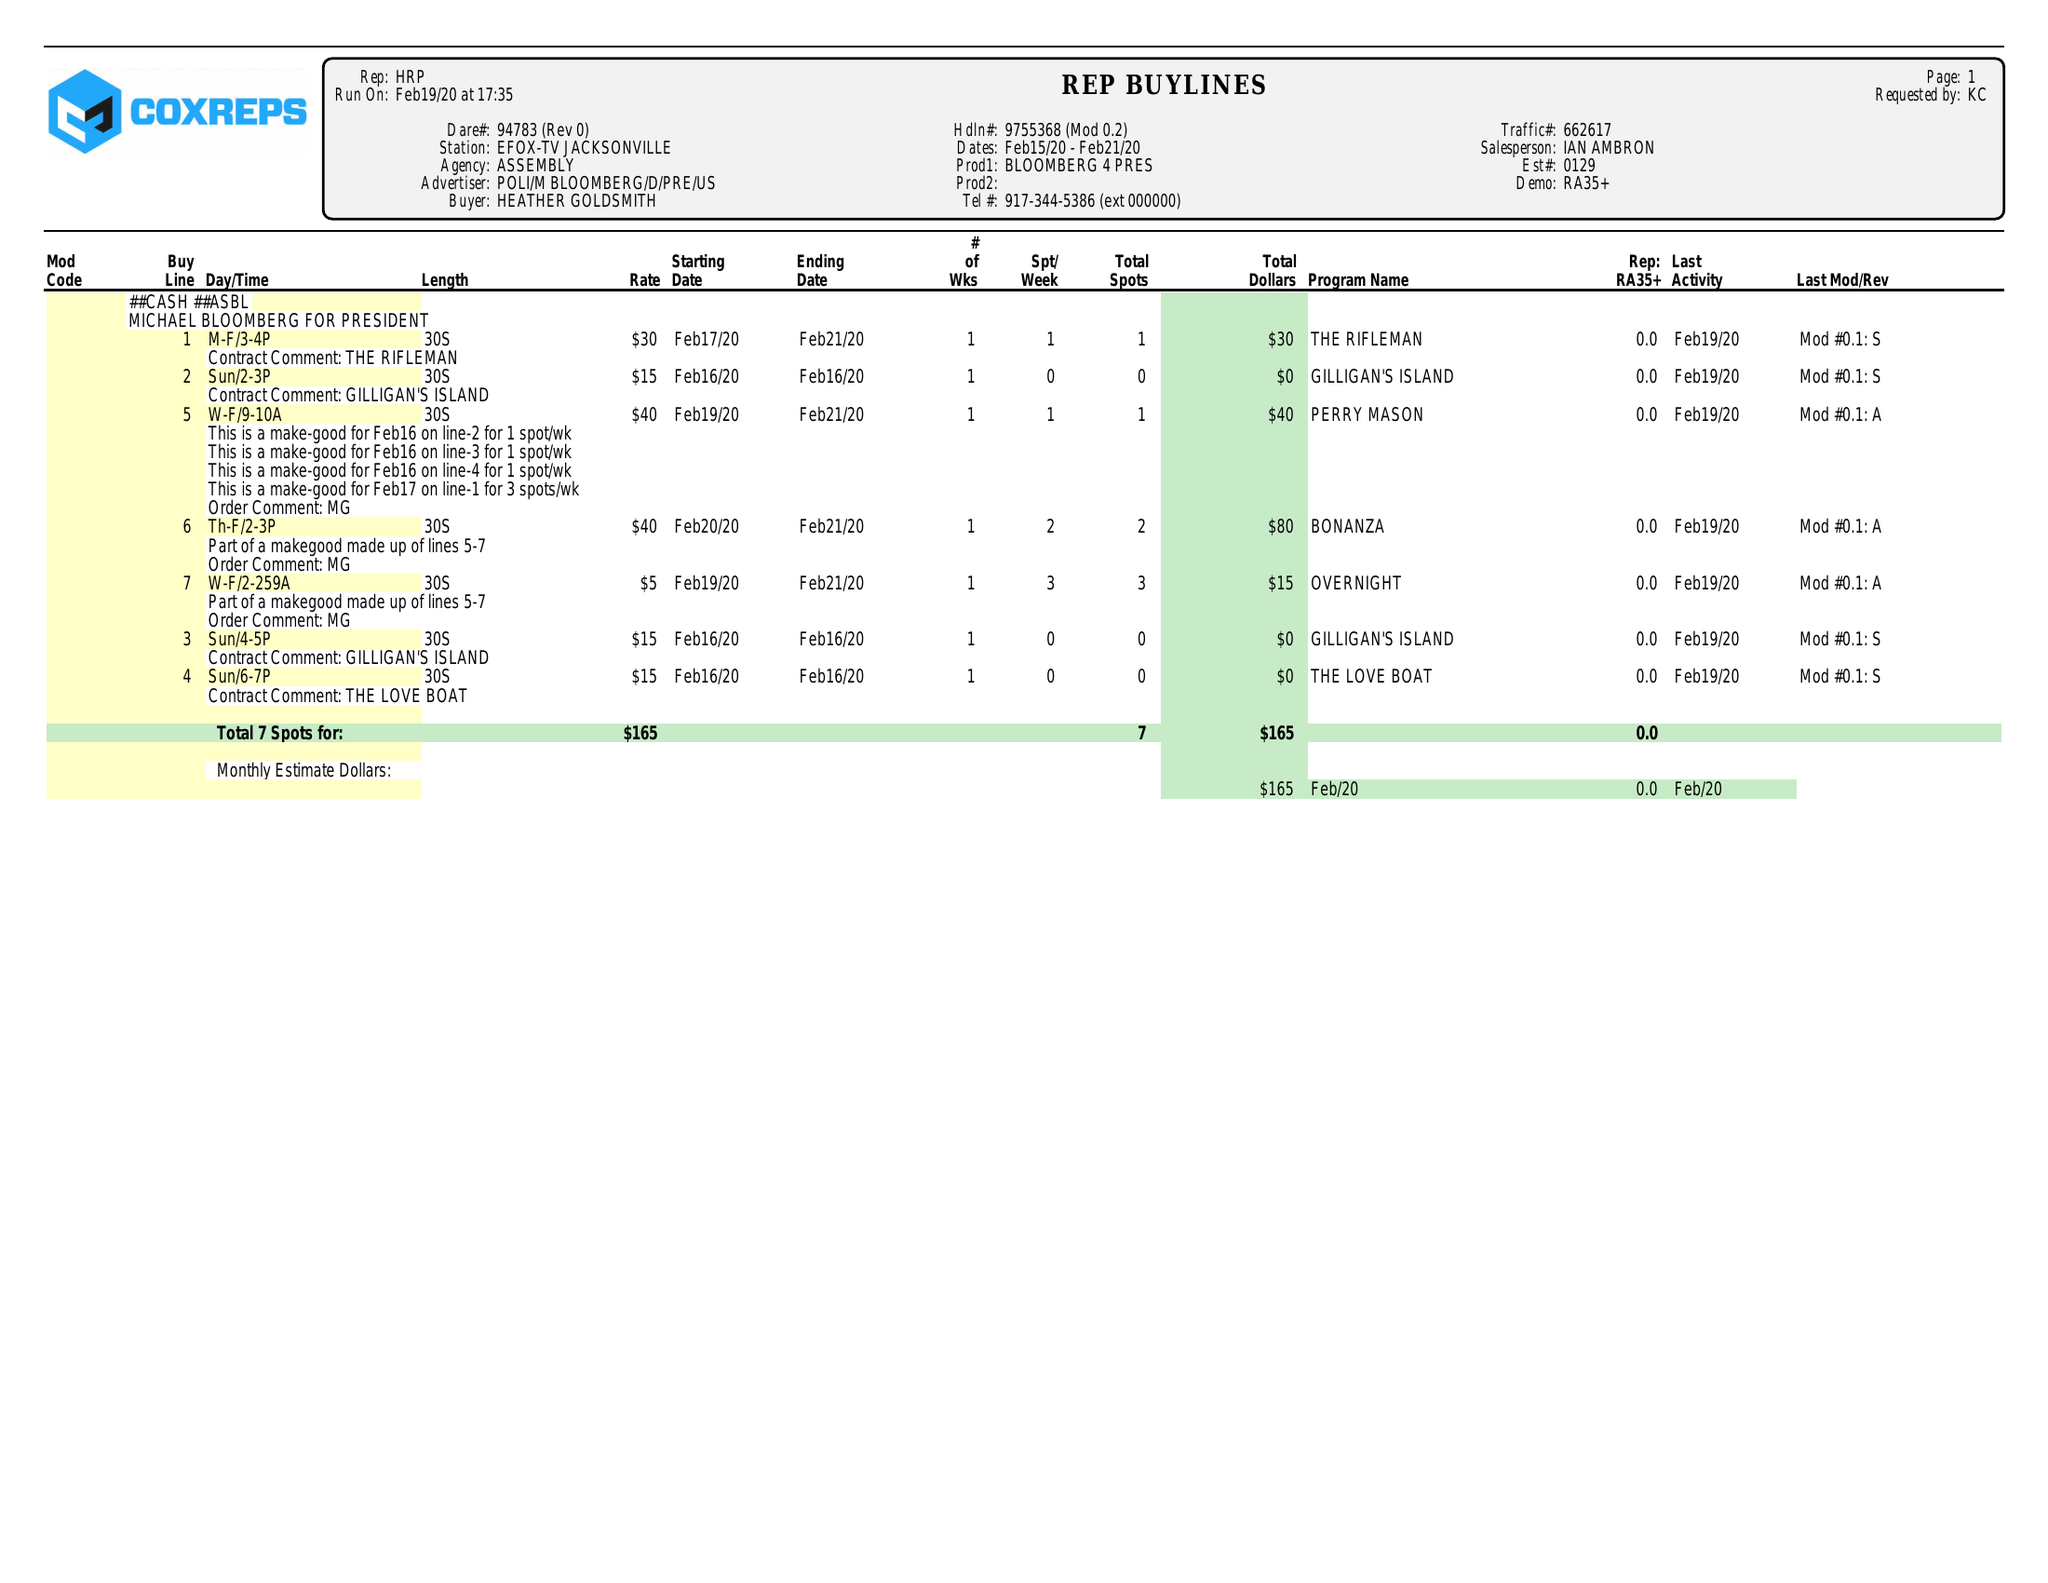What is the value for the flight_from?
Answer the question using a single word or phrase. 02/19/20 